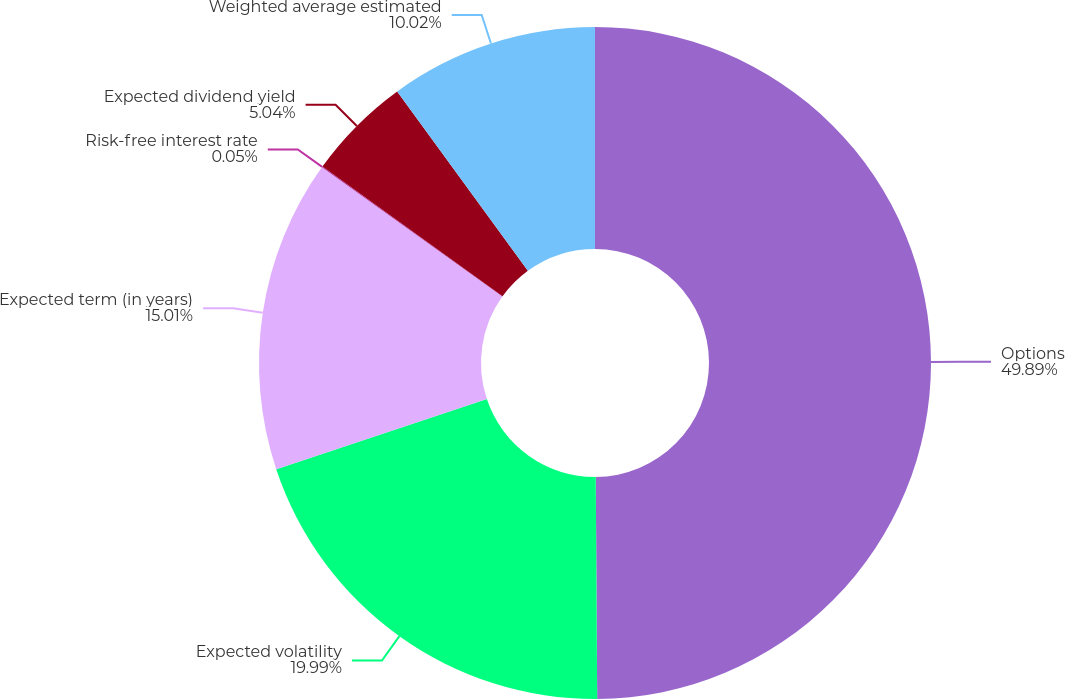Convert chart to OTSL. <chart><loc_0><loc_0><loc_500><loc_500><pie_chart><fcel>Options<fcel>Expected volatility<fcel>Expected term (in years)<fcel>Risk-free interest rate<fcel>Expected dividend yield<fcel>Weighted average estimated<nl><fcel>49.9%<fcel>19.99%<fcel>15.01%<fcel>0.05%<fcel>5.04%<fcel>10.02%<nl></chart> 